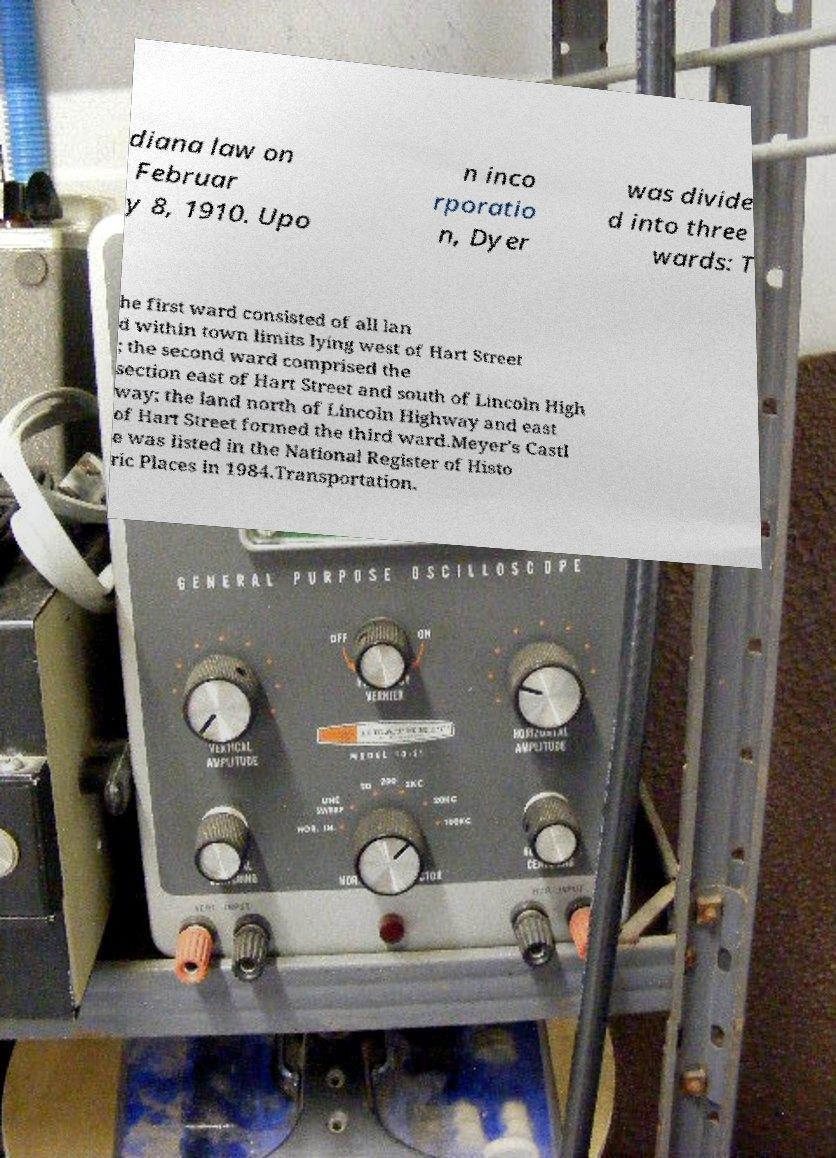Can you read and provide the text displayed in the image?This photo seems to have some interesting text. Can you extract and type it out for me? diana law on Februar y 8, 1910. Upo n inco rporatio n, Dyer was divide d into three wards: T he first ward consisted of all lan d within town limits lying west of Hart Street ; the second ward comprised the section east of Hart Street and south of Lincoln High way; the land north of Lincoln Highway and east of Hart Street formed the third ward.Meyer's Castl e was listed in the National Register of Histo ric Places in 1984.Transportation. 